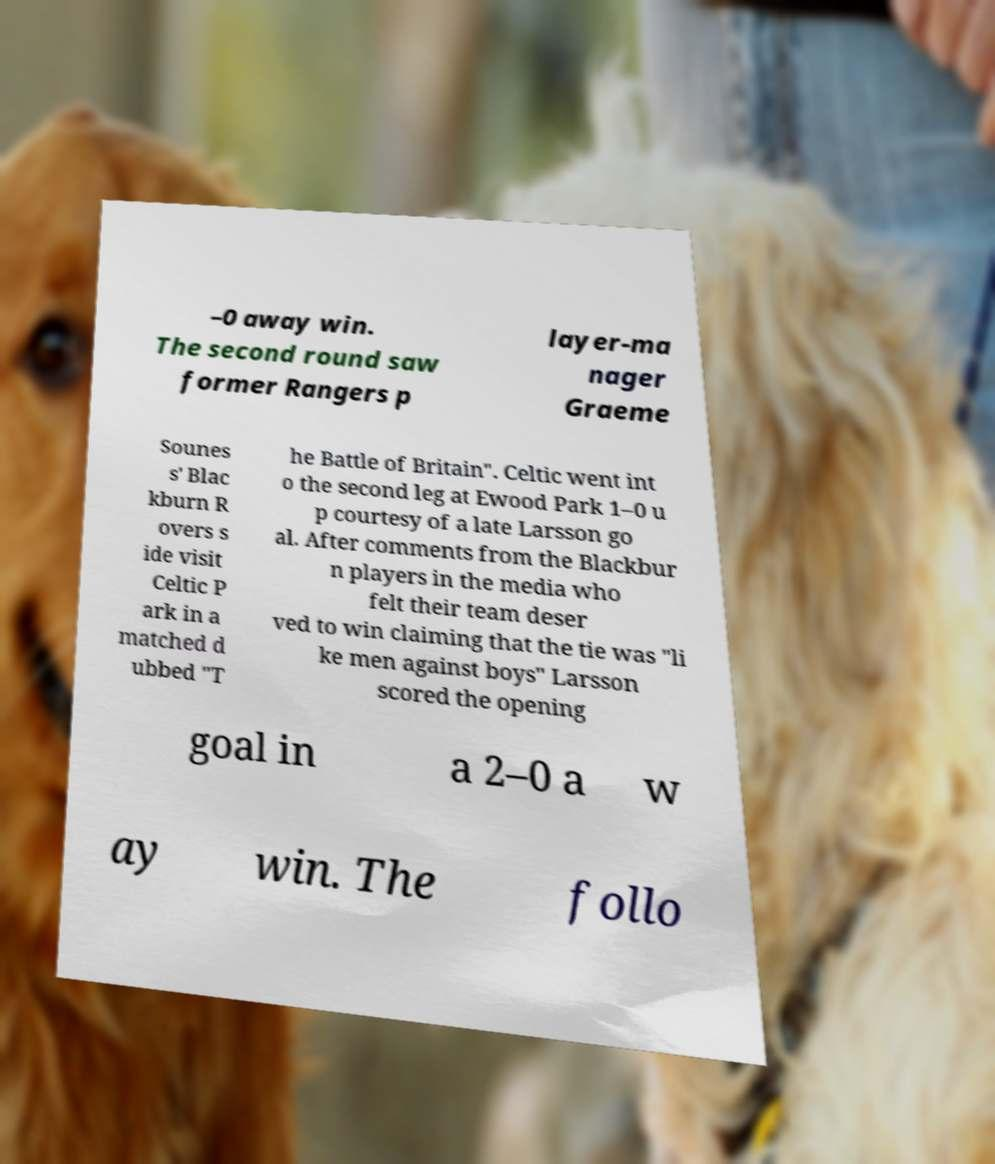Could you assist in decoding the text presented in this image and type it out clearly? –0 away win. The second round saw former Rangers p layer-ma nager Graeme Sounes s' Blac kburn R overs s ide visit Celtic P ark in a matched d ubbed "T he Battle of Britain". Celtic went int o the second leg at Ewood Park 1–0 u p courtesy of a late Larsson go al. After comments from the Blackbur n players in the media who felt their team deser ved to win claiming that the tie was "li ke men against boys" Larsson scored the opening goal in a 2–0 a w ay win. The follo 